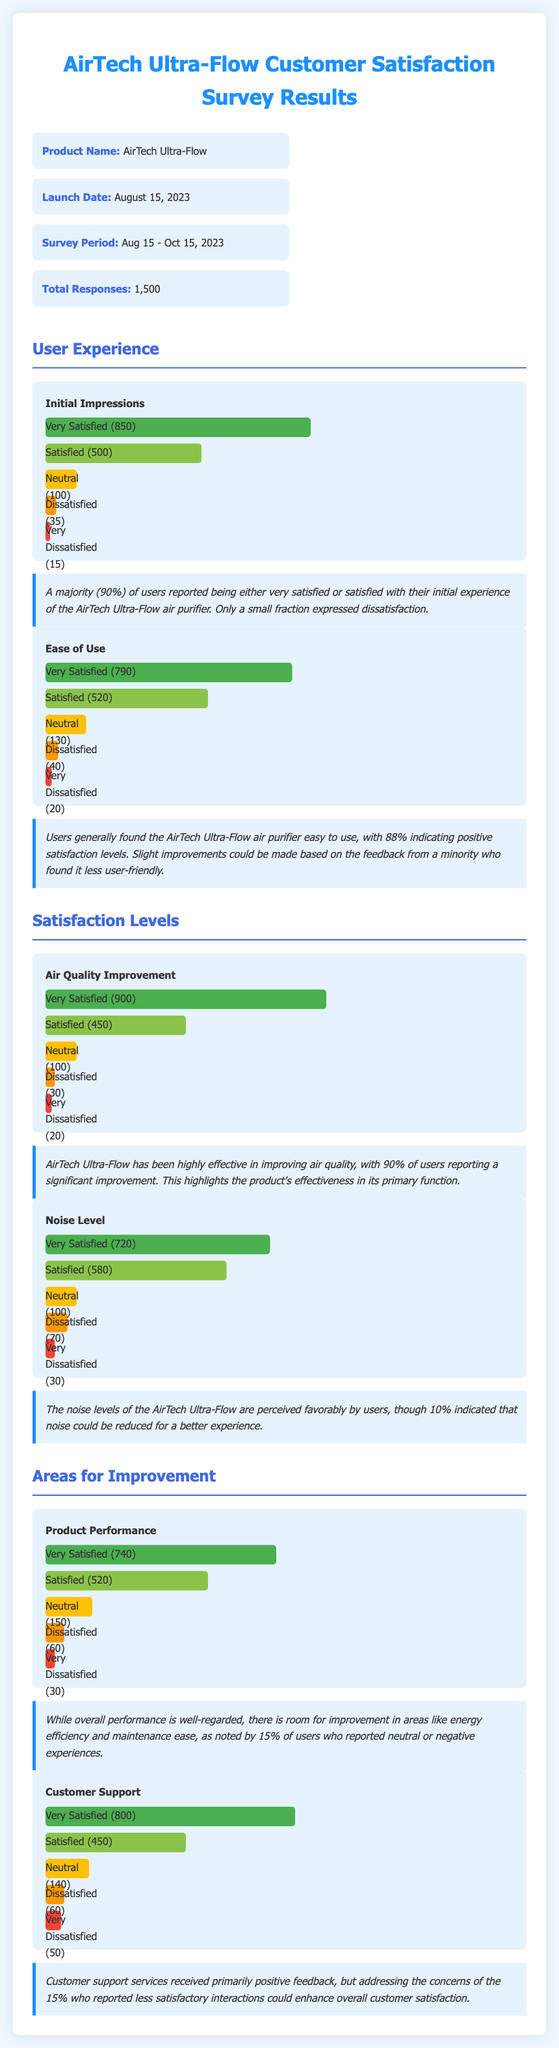What is the product name? The product name is listed in the overview section of the document as AirTech Ultra-Flow.
Answer: AirTech Ultra-Flow What was the survey period? The survey period is specified in the overview section, indicating when the survey was conducted.
Answer: Aug 15 - Oct 15, 2023 How many total responses were collected? The document states the total number of responses collected for the survey in the overview section.
Answer: 1,500 What percentage of users were very satisfied with initial impressions? The document provides the percentage of users who reported being very satisfied in the initial impressions chart.
Answer: 56.7% What improvement area had the lowest satisfaction level? By comparing the satisfaction levels across areas, the lowest satisfaction can be identified in the product performance section.
Answer: Product Performance How many users reported dissatisfaction with customer support? The number of users who reported dissatisfaction with customer support is given in the corresponding chart.
Answer: 60 What is the primary function of the AirTech Ultra-Flow air purifier? The effectiveness of the product in improving air quality hints at its primary function mentioned in the insights section.
Answer: Air quality improvement What aspect of the product did 10% of users want to see improvement in? The document indicates users wanted to see improvement in the noise levels of the air purifier based on survey responses.
Answer: Noise level 